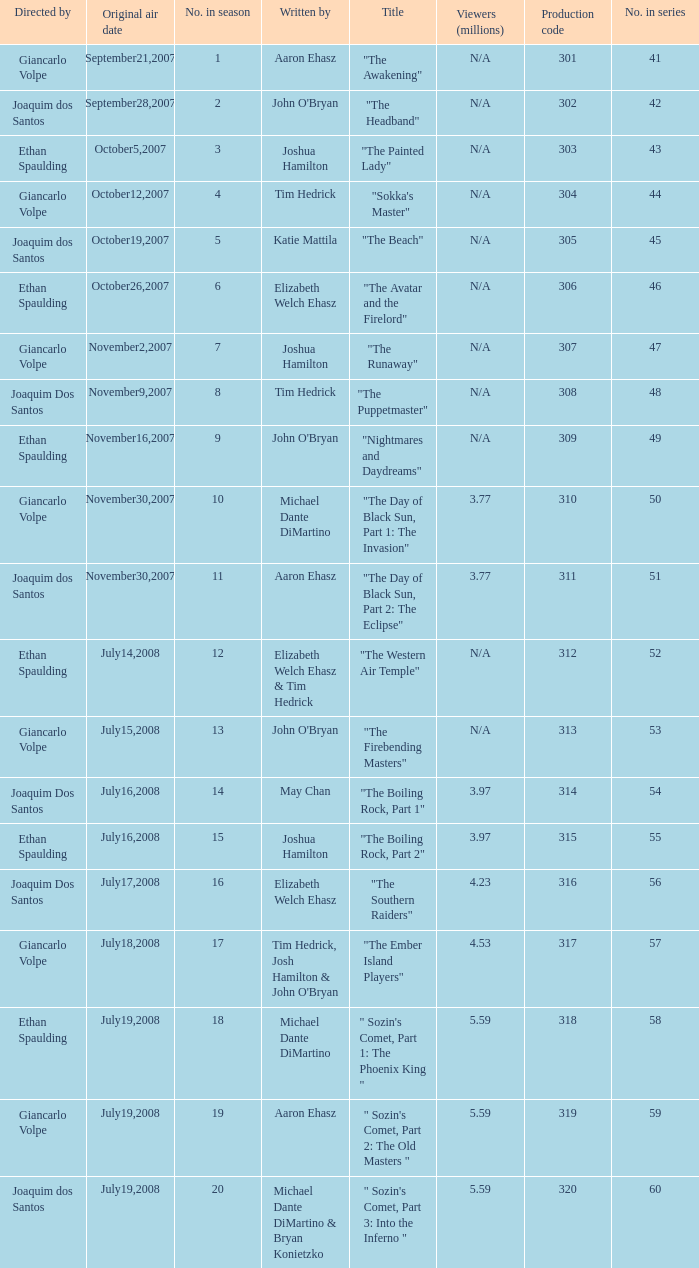I'm looking to parse the entire table for insights. Could you assist me with that? {'header': ['Directed by', 'Original air date', 'No. in season', 'Written by', 'Title', 'Viewers (millions)', 'Production code', 'No. in series'], 'rows': [['Giancarlo Volpe', 'September21,2007', '1', 'Aaron Ehasz', '"The Awakening"', 'N/A', '301', '41'], ['Joaquim dos Santos', 'September28,2007', '2', "John O'Bryan", '"The Headband"', 'N/A', '302', '42'], ['Ethan Spaulding', 'October5,2007', '3', 'Joshua Hamilton', '"The Painted Lady"', 'N/A', '303', '43'], ['Giancarlo Volpe', 'October12,2007', '4', 'Tim Hedrick', '"Sokka\'s Master"', 'N/A', '304', '44'], ['Joaquim dos Santos', 'October19,2007', '5', 'Katie Mattila', '"The Beach"', 'N/A', '305', '45'], ['Ethan Spaulding', 'October26,2007', '6', 'Elizabeth Welch Ehasz', '"The Avatar and the Firelord"', 'N/A', '306', '46'], ['Giancarlo Volpe', 'November2,2007', '7', 'Joshua Hamilton', '"The Runaway"', 'N/A', '307', '47'], ['Joaquim Dos Santos', 'November9,2007', '8', 'Tim Hedrick', '"The Puppetmaster"', 'N/A', '308', '48'], ['Ethan Spaulding', 'November16,2007', '9', "John O'Bryan", '"Nightmares and Daydreams"', 'N/A', '309', '49'], ['Giancarlo Volpe', 'November30,2007', '10', 'Michael Dante DiMartino', '"The Day of Black Sun, Part 1: The Invasion"', '3.77', '310', '50'], ['Joaquim dos Santos', 'November30,2007', '11', 'Aaron Ehasz', '"The Day of Black Sun, Part 2: The Eclipse"', '3.77', '311', '51'], ['Ethan Spaulding', 'July14,2008', '12', 'Elizabeth Welch Ehasz & Tim Hedrick', '"The Western Air Temple"', 'N/A', '312', '52'], ['Giancarlo Volpe', 'July15,2008', '13', "John O'Bryan", '"The Firebending Masters"', 'N/A', '313', '53'], ['Joaquim Dos Santos', 'July16,2008', '14', 'May Chan', '"The Boiling Rock, Part 1"', '3.97', '314', '54'], ['Ethan Spaulding', 'July16,2008', '15', 'Joshua Hamilton', '"The Boiling Rock, Part 2"', '3.97', '315', '55'], ['Joaquim Dos Santos', 'July17,2008', '16', 'Elizabeth Welch Ehasz', '"The Southern Raiders"', '4.23', '316', '56'], ['Giancarlo Volpe', 'July18,2008', '17', "Tim Hedrick, Josh Hamilton & John O'Bryan", '"The Ember Island Players"', '4.53', '317', '57'], ['Ethan Spaulding', 'July19,2008', '18', 'Michael Dante DiMartino', '" Sozin\'s Comet, Part 1: The Phoenix King "', '5.59', '318', '58'], ['Giancarlo Volpe', 'July19,2008', '19', 'Aaron Ehasz', '" Sozin\'s Comet, Part 2: The Old Masters "', '5.59', '319', '59'], ['Joaquim dos Santos', 'July19,2008', '20', 'Michael Dante DiMartino & Bryan Konietzko', '" Sozin\'s Comet, Part 3: Into the Inferno "', '5.59', '320', '60']]} What season has an episode written by john o'bryan and directed by ethan spaulding? 9.0. 